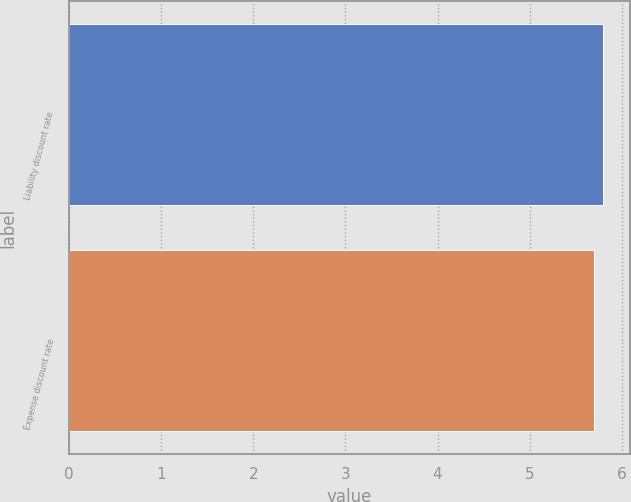Convert chart. <chart><loc_0><loc_0><loc_500><loc_500><bar_chart><fcel>Liability discount rate<fcel>Expense discount rate<nl><fcel>5.8<fcel>5.7<nl></chart> 